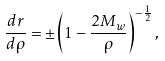<formula> <loc_0><loc_0><loc_500><loc_500>\frac { d r } { d \rho } = \pm \left ( 1 - \frac { 2 M _ { w } } { \rho } \right ) ^ { - \frac { 1 } { 2 } } ,</formula> 